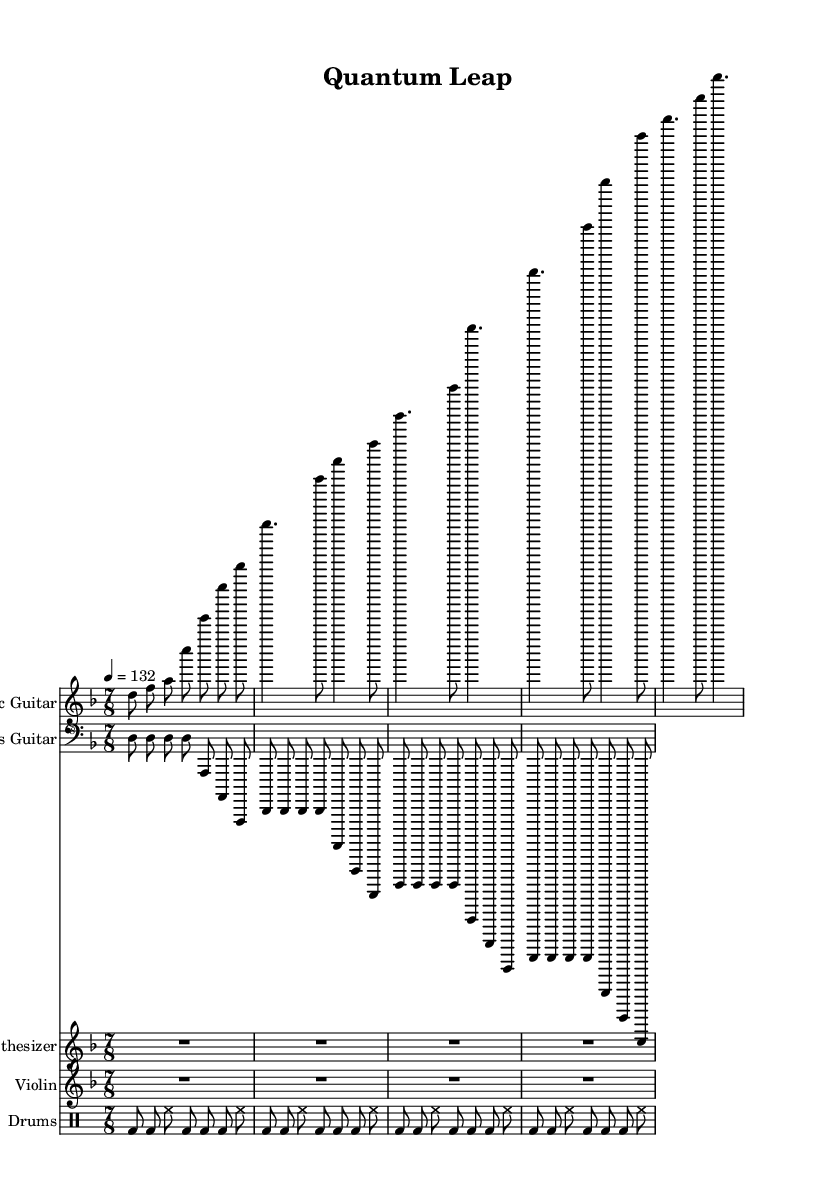What is the key signature of this music? The key signature is D minor, which has one flat (B flat). This is indicated at the beginning of the sheet music.
Answer: D minor What is the time signature of the piece? The time signature shown in the music is 7/8, which means there are seven eighth notes in each measure. This is explicitly noted at the beginning of the score.
Answer: 7/8 What is the tempo marking for this song? The tempo marking is indicated as quarter note equals 132 beats per minute. This is specified in the tempo section of the sheet music.
Answer: 132 How many measures are in the electric guitar part? Counting the measures in the electric guitar part, there are 5 measures total in the provided excerpt.
Answer: 5 Which instrument is playing the rhythmic rest in the first section? The synthesizer and violin parts are indicated as having whole rests in the first section, which is reflected as R1 in the score notation.
Answer: Synthesizer, Violin What is the main rhythmic pattern in the drum part? The drum pattern contributes a driving rhythm characterized by a kick drum on beats and hi-hat emphasizing the upbeat, occurring repeatedly across the measures.
Answer: Kick drum and hi-hat rhythm 